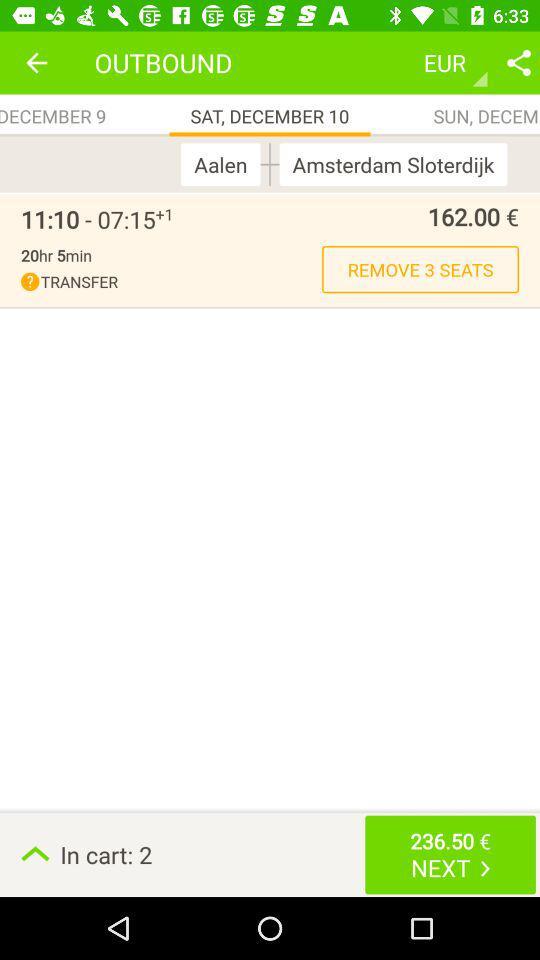What is the price of the ticket? The price of the ticket is 162.00 €. 